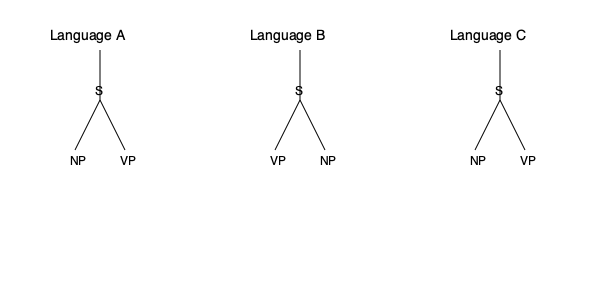Based on the syntactic tree structures shown for Languages A, B, and C, which language exhibits a different word order pattern compared to the others, and what type of word order does it likely represent? To answer this question, we need to analyze the syntactic tree structures for each language:

1. Language A:
   - The structure is S → NP VP
   - This represents a Subject-Verb-Object (SVO) word order

2. Language B:
   - The structure is S → VP NP
   - This represents a different word order from A and C

3. Language C:
   - The structure is S → NP VP
   - This is identical to Language A, representing SVO word order

4. Comparing the structures:
   - Languages A and C have the same NP VP order under S
   - Language B has a VP NP order under S, which is different

5. Identifying the different word order:
   - Language B stands out with its VP NP structure
   - This likely represents a Verb-Subject-Object (VSO) or Verb-Object-Subject (VOS) word order

6. Concluding the analysis:
   - Language B exhibits a different word order pattern
   - It likely represents a VSO or VOS word order, as opposed to the SVO order of Languages A and C
Answer: Language B; VSO or VOS word order 